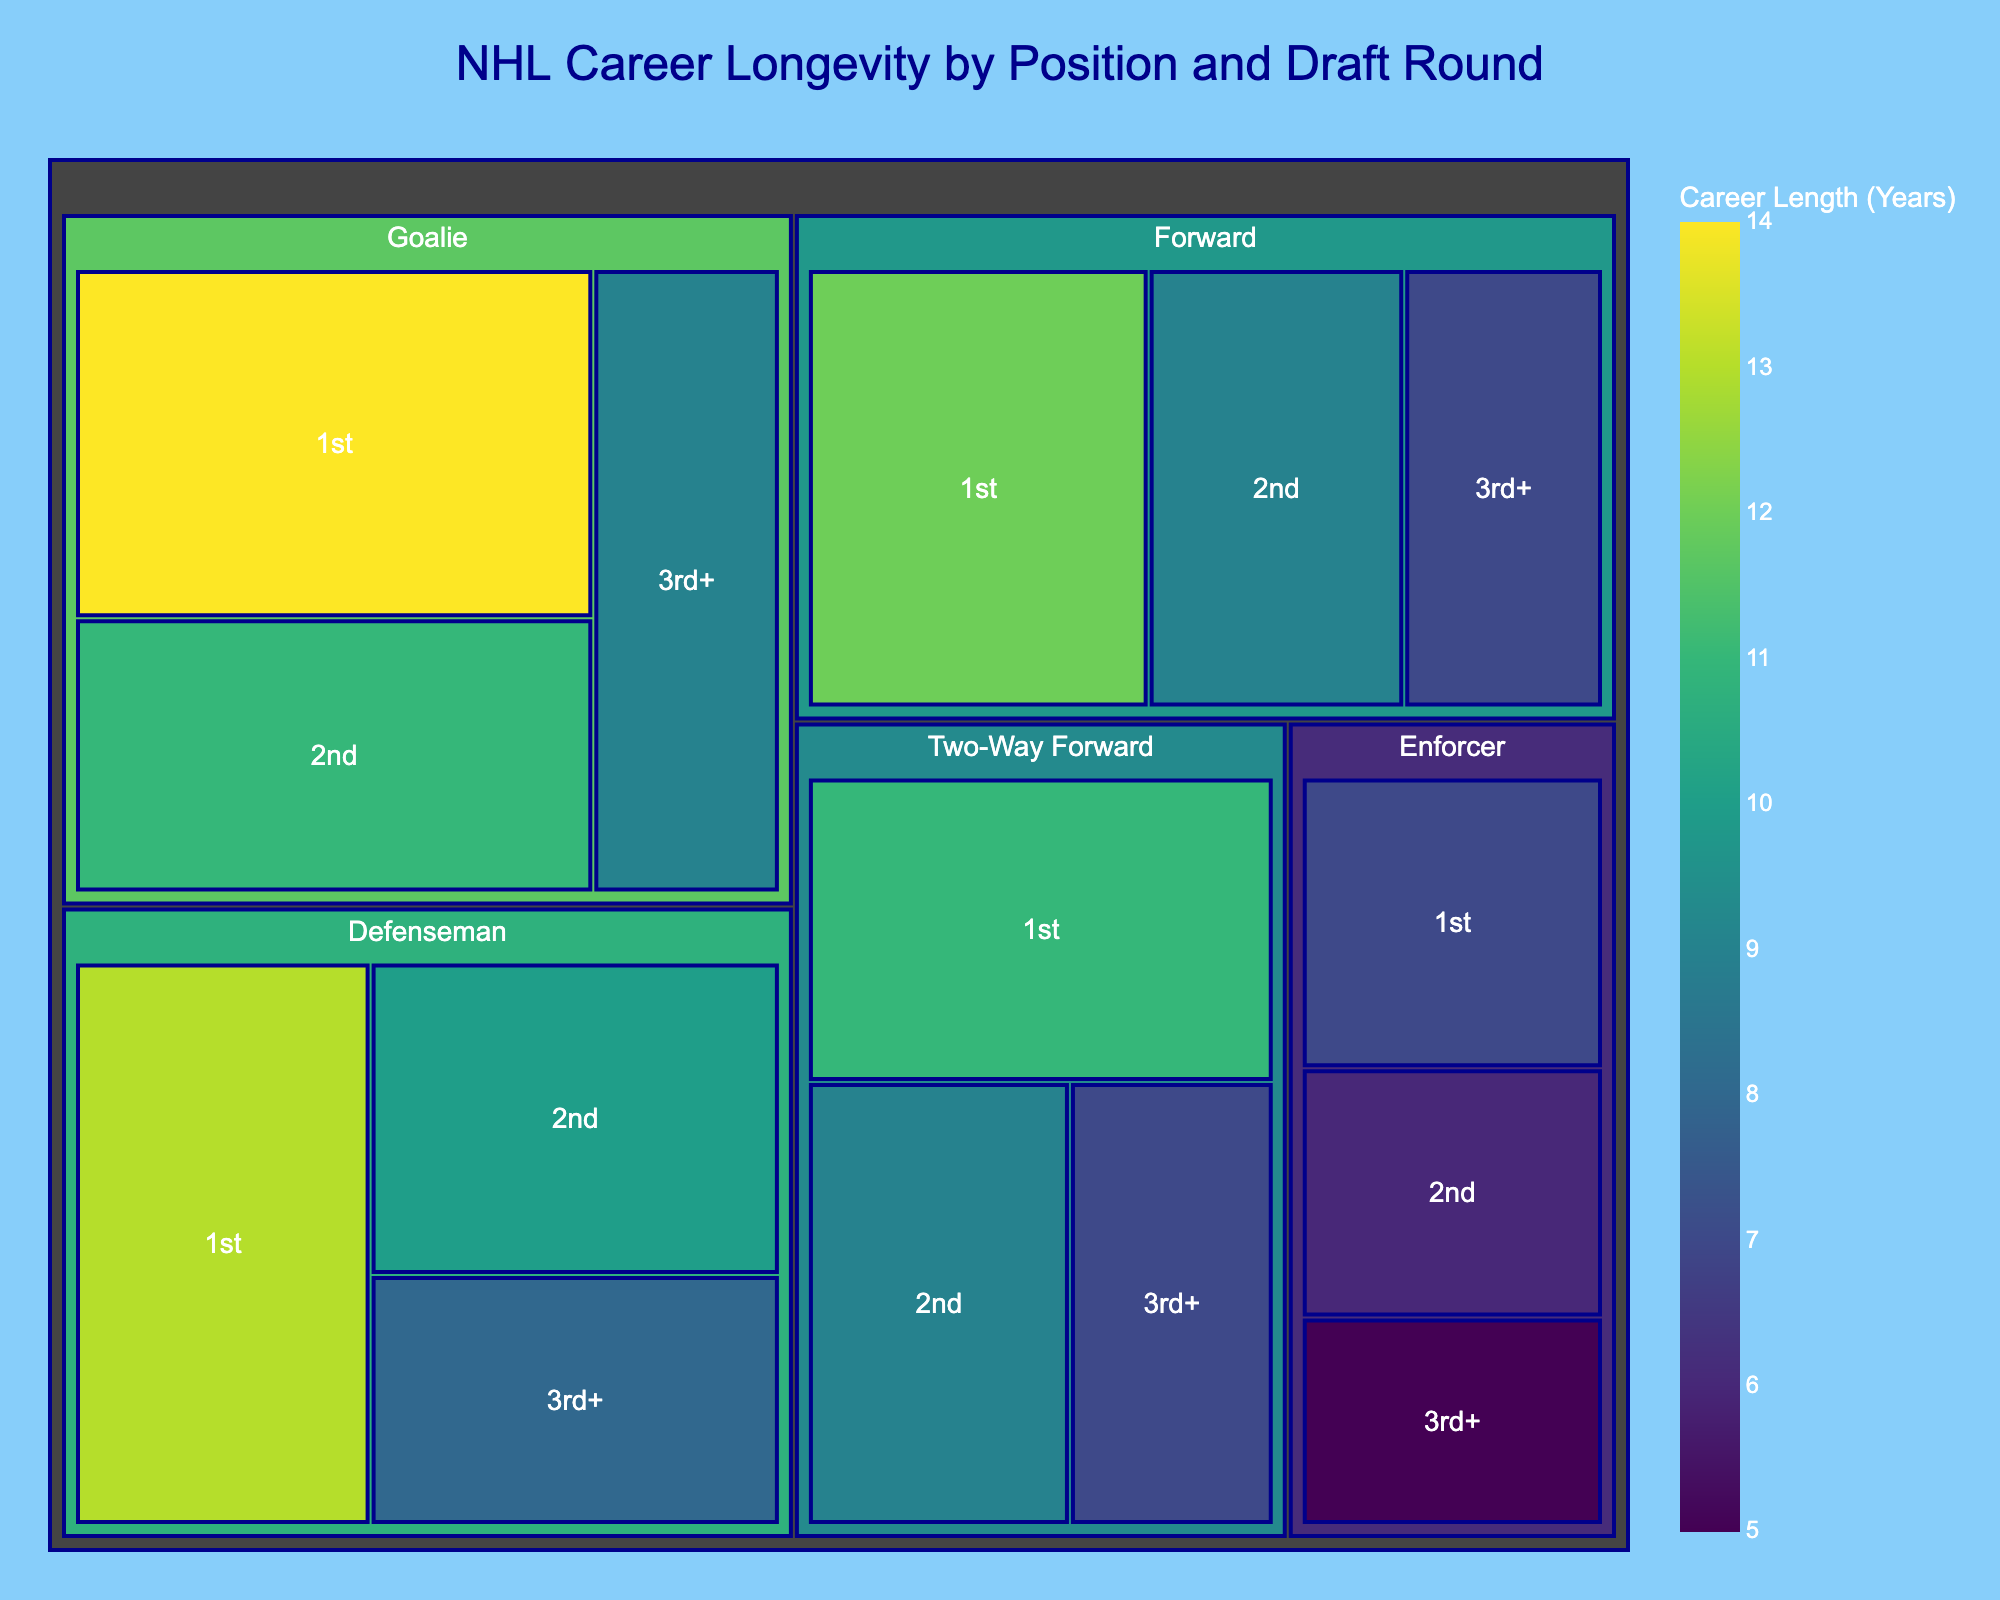What's the title of the treemap? The title is displayed prominently at the top of the treemap. It summarizes the subject of the visualization.
Answer: NHL Career Longevity by Position and Draft Round Which position has the longest career length? Look at the different colors and sizes of the sections representing each position. The one with the largest value for career length across draft rounds is the longest.
Answer: Goalie What's the longest career length for a defenseman drafted in 1st round? Find the section labeled 'Defenseman > 1st'. The value within this section is the career length.
Answer: 13 years Which positions have a median career length of 9 years or more? Identify the median values across different positions and draft rounds, then compare them to 9 years.
Answer: Defenseman, Goalie, and Two-Way Forward How does the career length of forwards drafted in the 2nd round compare to those drafted in the 3rd+ round? Compare the values in the sections 'Forward > 2nd' and 'Forward > 3rd+'. The career lengths are visible in the respective sections.
Answer: 2nd round - 9 years; 3rd+ round - 7 years Which draft round has the shortest average career length for enforcers? Calculate the average career length for enforcers across all draft rounds and find the smallest value.
Answer: 3rd+ round What color scheme is used to represent career lengths? The color of the sections represents career length values, so identify the color scale or palette from the legend or color bar.
Answer: Viridis What's the total career length of goalies drafted in the 1st and 2nd rounds combined? Sum the career lengths of goalies drafted in the 1st round and 2nd round.
Answer: 25 years (14 + 11) Which has a greater career length: enforcers drafted in the 1st round or two-way forwards drafted in the 3rd+ round? Compare the values in the sections 'Enforcer > 1st' and 'Two-Way Forward > 3rd+'.
Answer: Two-Way Forward drafted in the 3rd+ round What is the range of career lengths for defensemen across all draft rounds? Identify the minimum and maximum career length values for defensemen from the treemap and calculate the difference.
Answer: 8 to 13 years 